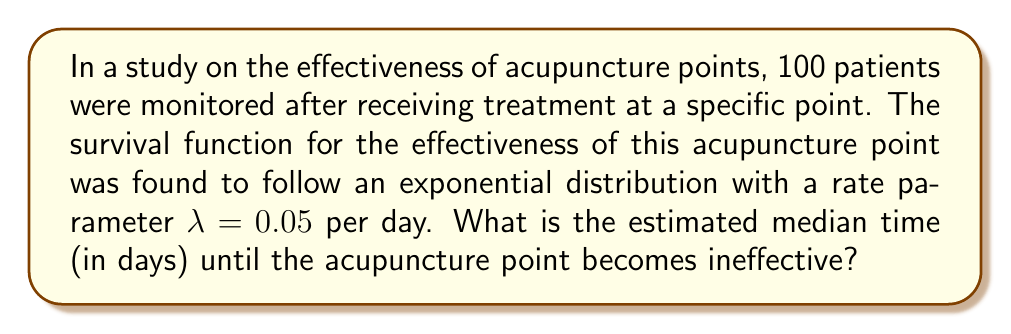Show me your answer to this math problem. Let's approach this step-by-step:

1) For an exponential distribution, the survival function is given by:
   $$S(t) = e^{-\lambda t}$$

2) The median time is the point at which the survival function equals 0.5. So we need to solve:
   $$S(t) = 0.5$$

3) Substituting the survival function:
   $$e^{-\lambda t} = 0.5$$

4) Taking the natural logarithm of both sides:
   $$-\lambda t = \ln(0.5)$$

5) Solving for t:
   $$t = -\frac{\ln(0.5)}{\lambda}$$

6) We know that $\lambda = 0.05$ per day. Substituting this:
   $$t = -\frac{\ln(0.5)}{0.05}$$

7) Calculating:
   $$t = -\frac{-0.6931}{0.05} \approx 13.86 \text{ days}$$

Therefore, the estimated median time until the acupuncture point becomes ineffective is approximately 13.86 days.
Answer: 13.86 days 